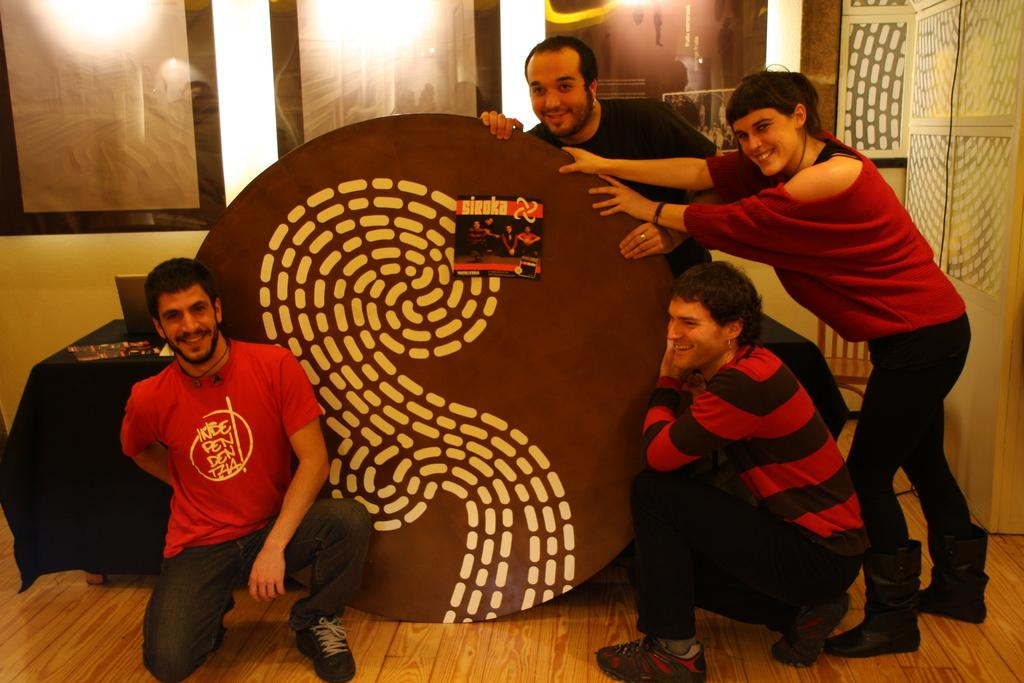What is the position of the man in the image? There is a man sitting on the floor in the image. What are the people at the back of the image doing? The people are standing at the back in the image and holding a board. What is on the board that the people are holding? There is a poster on the board. Can you see any mist in the image? There is no mention of mist in the provided facts, and therefore it cannot be determined if mist is present in the image. What color are the man's toes in the image? The provided facts do not mention the man's toes, so we cannot determine their color from the image. 